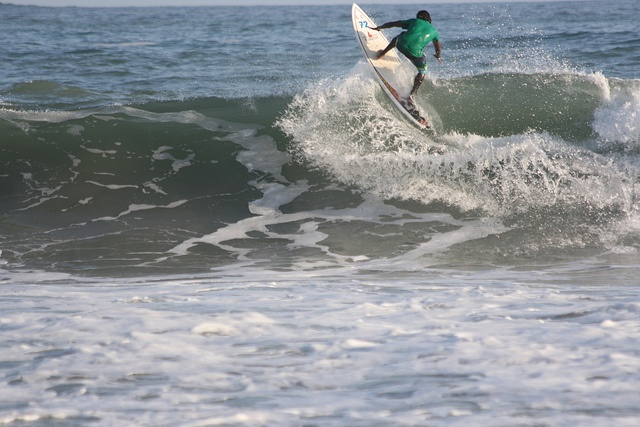Describe the objects in this image and their specific colors. I can see surfboard in darkgray, ivory, tan, and gray tones and people in darkgray, black, teal, and gray tones in this image. 